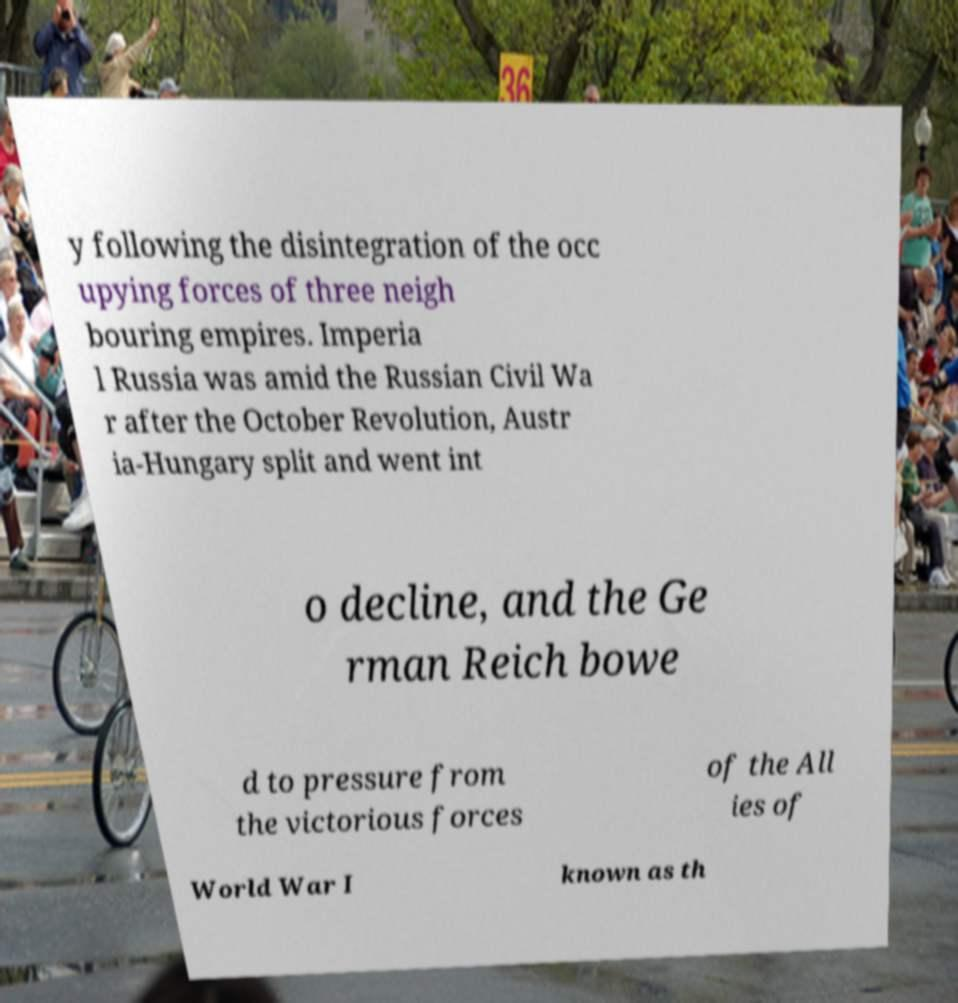Could you assist in decoding the text presented in this image and type it out clearly? y following the disintegration of the occ upying forces of three neigh bouring empires. Imperia l Russia was amid the Russian Civil Wa r after the October Revolution, Austr ia-Hungary split and went int o decline, and the Ge rman Reich bowe d to pressure from the victorious forces of the All ies of World War I known as th 